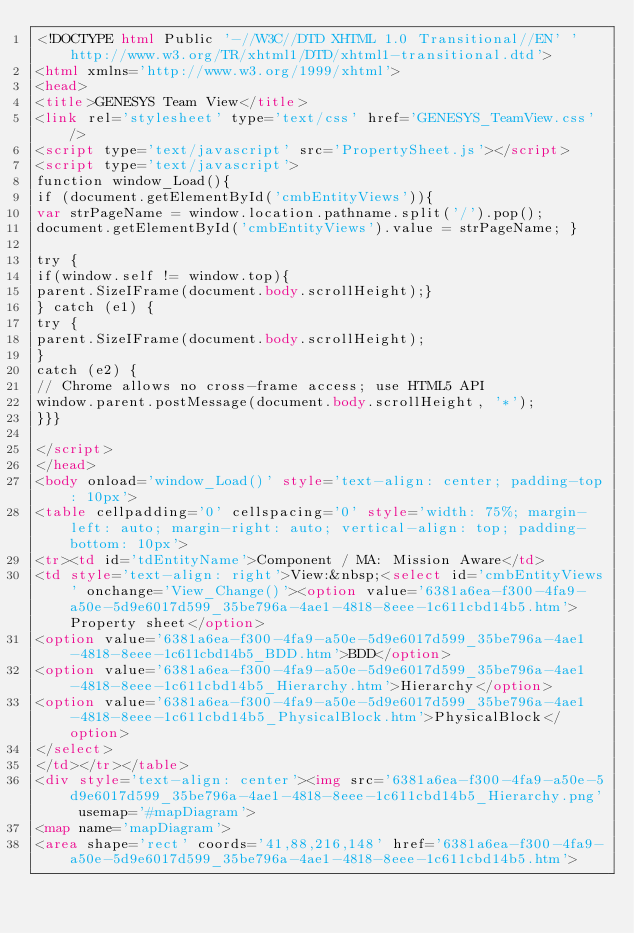Convert code to text. <code><loc_0><loc_0><loc_500><loc_500><_HTML_><!DOCTYPE html Public '-//W3C//DTD XHTML 1.0 Transitional//EN' 'http://www.w3.org/TR/xhtml1/DTD/xhtml1-transitional.dtd'>
<html xmlns='http://www.w3.org/1999/xhtml'>
<head>
<title>GENESYS Team View</title>
<link rel='stylesheet' type='text/css' href='GENESYS_TeamView.css'/>
<script type='text/javascript' src='PropertySheet.js'></script>
<script type='text/javascript'>
function window_Load(){
if (document.getElementById('cmbEntityViews')){
var strPageName = window.location.pathname.split('/').pop();
document.getElementById('cmbEntityViews').value = strPageName; }

try {
if(window.self != window.top){
parent.SizeIFrame(document.body.scrollHeight);}
} catch (e1) {
try {
parent.SizeIFrame(document.body.scrollHeight);
}
catch (e2) {
// Chrome allows no cross-frame access; use HTML5 API
window.parent.postMessage(document.body.scrollHeight, '*');
}}}

</script>
</head>
<body onload='window_Load()' style='text-align: center; padding-top: 10px'>
<table cellpadding='0' cellspacing='0' style='width: 75%; margin-left: auto; margin-right: auto; vertical-align: top; padding-bottom: 10px'>
<tr><td id='tdEntityName'>Component / MA: Mission Aware</td>
<td style='text-align: right'>View:&nbsp;<select id='cmbEntityViews' onchange='View_Change()'><option value='6381a6ea-f300-4fa9-a50e-5d9e6017d599_35be796a-4ae1-4818-8eee-1c611cbd14b5.htm'>Property sheet</option>
<option value='6381a6ea-f300-4fa9-a50e-5d9e6017d599_35be796a-4ae1-4818-8eee-1c611cbd14b5_BDD.htm'>BDD</option>
<option value='6381a6ea-f300-4fa9-a50e-5d9e6017d599_35be796a-4ae1-4818-8eee-1c611cbd14b5_Hierarchy.htm'>Hierarchy</option>
<option value='6381a6ea-f300-4fa9-a50e-5d9e6017d599_35be796a-4ae1-4818-8eee-1c611cbd14b5_PhysicalBlock.htm'>PhysicalBlock</option>
</select>
</td></tr></table>
<div style='text-align: center'><img src='6381a6ea-f300-4fa9-a50e-5d9e6017d599_35be796a-4ae1-4818-8eee-1c611cbd14b5_Hierarchy.png' usemap='#mapDiagram'>
<map name='mapDiagram'>
<area shape='rect' coords='41,88,216,148' href='6381a6ea-f300-4fa9-a50e-5d9e6017d599_35be796a-4ae1-4818-8eee-1c611cbd14b5.htm'></code> 